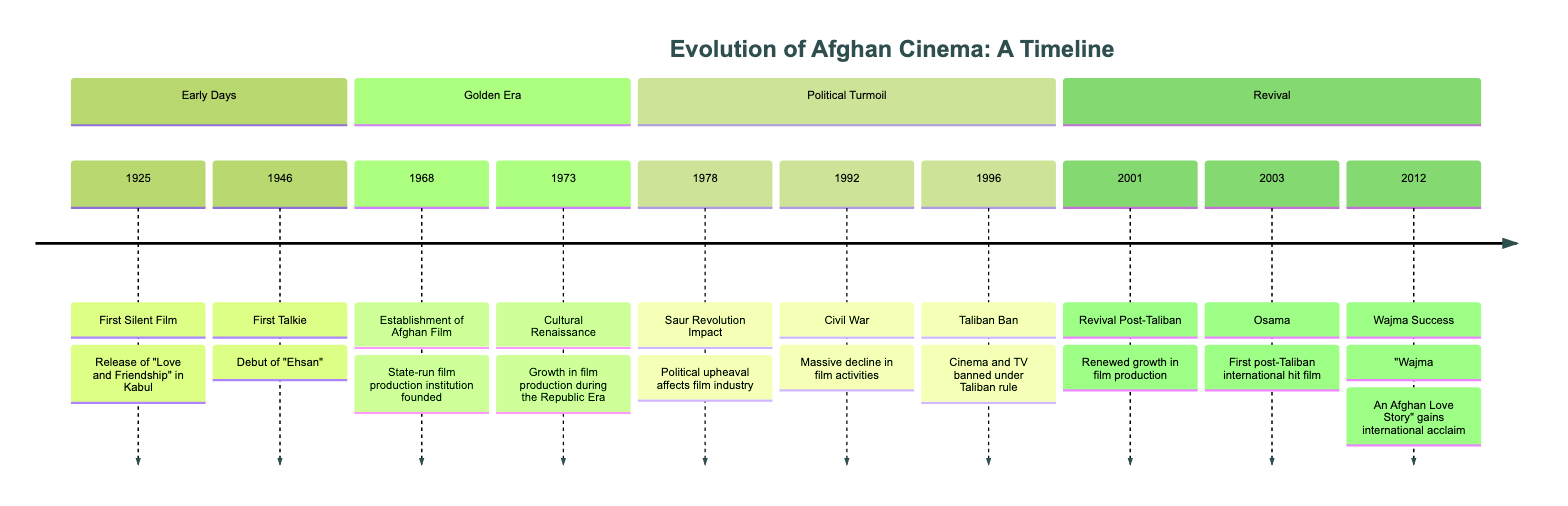What was the first silent film released in Afghanistan? The diagram indicates that the first silent film, "Love and Friendship," was released in 1925. I found this information in the Early Days section of the timeline.
Answer: Love and Friendship What year did the Taliban impose a ban on cinema and TV? According to the timeline, the Taliban Ban occurred in 1996 as noted in the Political Turmoil section. This specifies a critical moment affecting the Afghan cinema landscape.
Answer: 1996 How many significant periods are highlighted in the timeline? The diagram clearly delineates four distinct sections of Afghan cinema's evolution: Early Days, Golden Era, Political Turmoil, and Revival. Counting these sections gives a total of four major periods.
Answer: 4 Which film gained international acclaim in 2012? The timeline states that in 2012, "Wajma: An Afghan Love Story" was recognized for its international acclaim, highlighting its significant impact during the Revival section.
Answer: Wajma: An Afghan Love Story What event marked the decline of film activities in 1992? Referring to the Political Turmoil section, the diagram notes that a Civil War in 1992 led to a massive decline in film activities, indicating a major setback for the industry at that time.
Answer: Civil War What was established in 1968 that contributed to the Afghan film industry? The timeline indicates that the establishment of Afghan Film in 1968 created a state-run film production institution. This marks a significant development during the Golden Era of Afghan cinema.
Answer: Afghan Film Which film was the first post-Taliban international hit? From the timeline, the first post-Taliban international hit film is identified as "Osama," released in 2003. This points out a key moment of resurgence in Afghan cinema post the Taliban rule.
Answer: Osama What major revolution impacted the Afghan film industry in 1978? According to the timeline, the Saur Revolution in 1978 is cited as having a significant impact on the film industry, marking a shift due to political upheaval.
Answer: Saur Revolution 